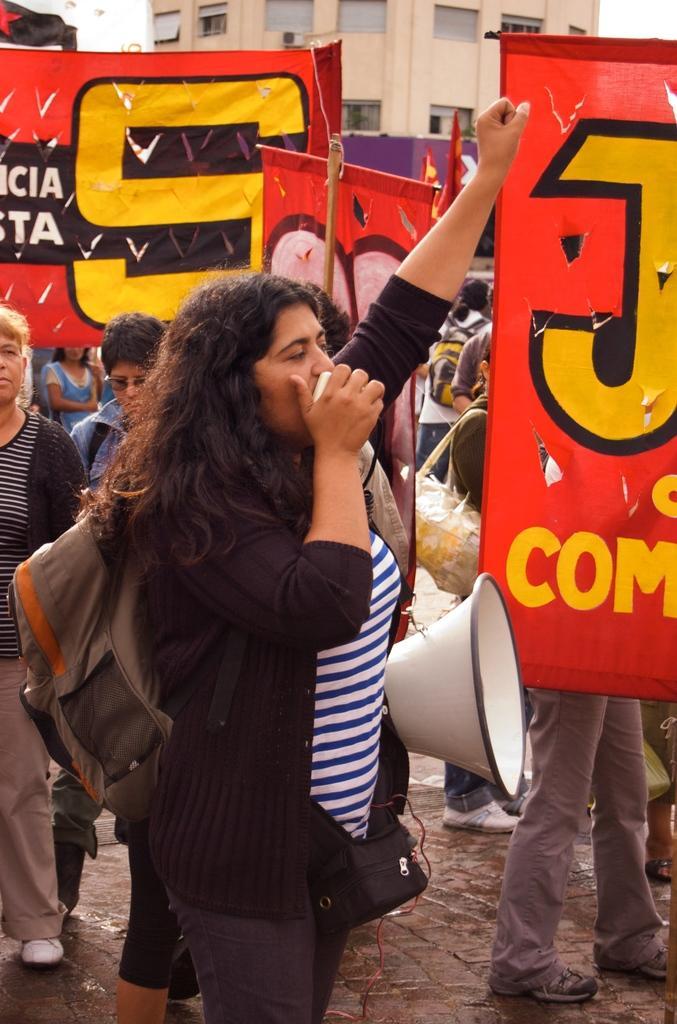In one or two sentences, can you explain what this image depicts? In this image we can see a woman is holding an object in her hand and carrying bag on her shoulders. In the background we can see a speaker, banners, few persons, building, windows and objects. 